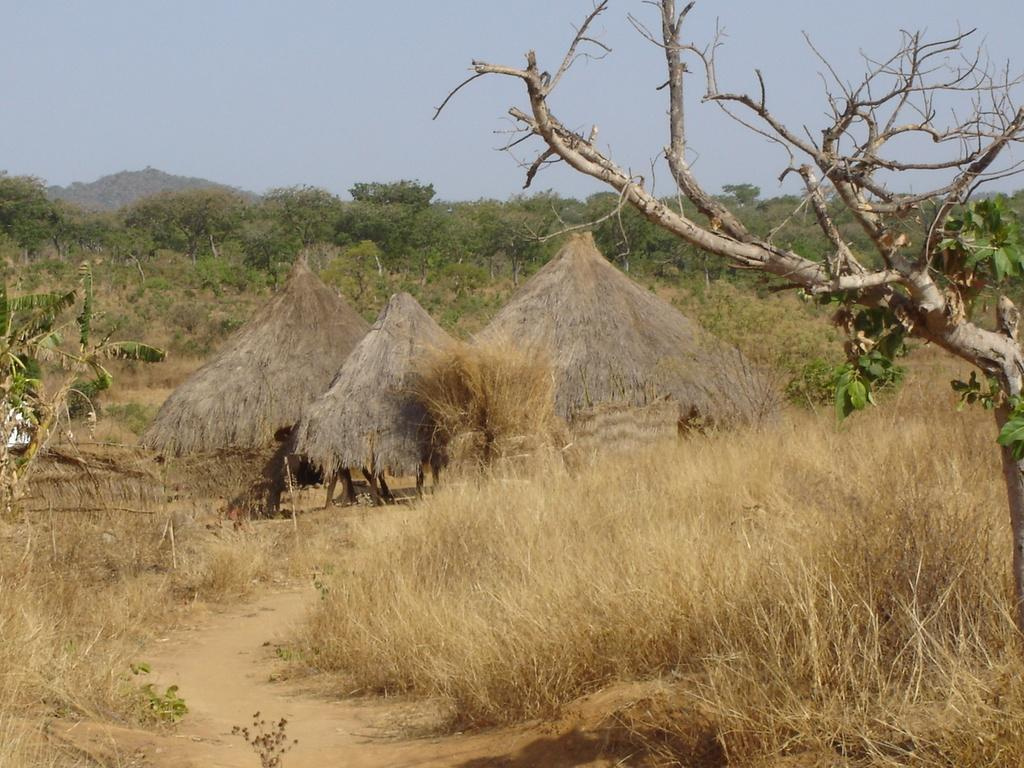What type of vegetation is present in the image? There is grass in the image. What structures can be seen in the middle of the image? There are three huts in the middle of the image. What can be seen in the background of the image? There are trees and the sky visible in the background of the image. What type of nail can be seen holding the huts together in the image? There is no nail visible in the image; the huts are not shown to be held together by any visible fasteners. 